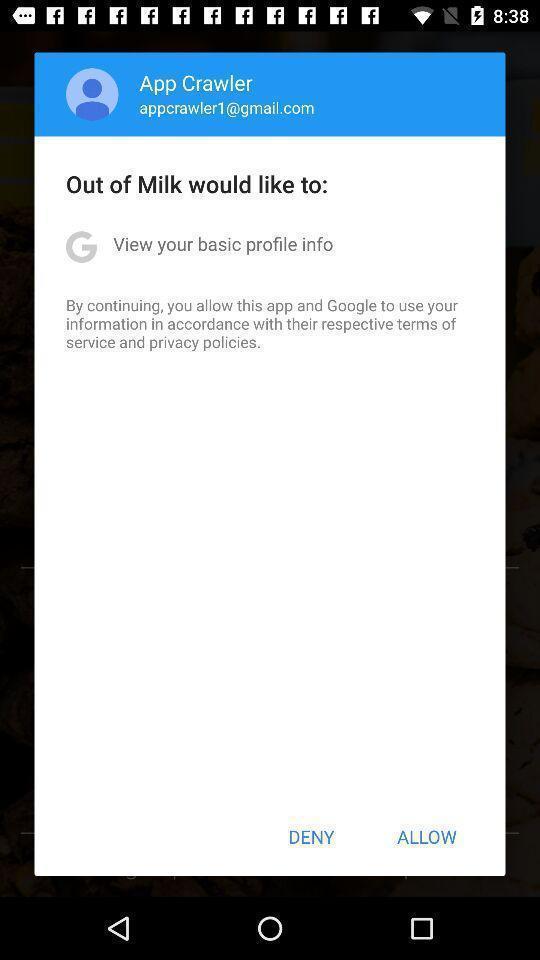Describe the content in this image. Pop-up asking for permission to allow access to personal data. 